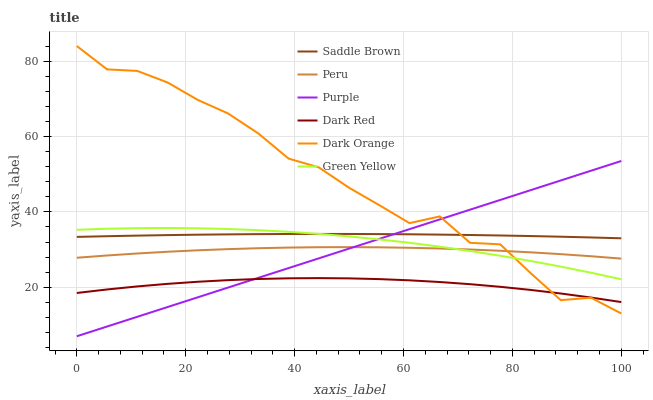Does Dark Red have the minimum area under the curve?
Answer yes or no. Yes. Does Dark Orange have the maximum area under the curve?
Answer yes or no. Yes. Does Purple have the minimum area under the curve?
Answer yes or no. No. Does Purple have the maximum area under the curve?
Answer yes or no. No. Is Purple the smoothest?
Answer yes or no. Yes. Is Dark Orange the roughest?
Answer yes or no. Yes. Is Dark Red the smoothest?
Answer yes or no. No. Is Dark Red the roughest?
Answer yes or no. No. Does Purple have the lowest value?
Answer yes or no. Yes. Does Dark Red have the lowest value?
Answer yes or no. No. Does Dark Orange have the highest value?
Answer yes or no. Yes. Does Purple have the highest value?
Answer yes or no. No. Is Dark Red less than Saddle Brown?
Answer yes or no. Yes. Is Peru greater than Dark Red?
Answer yes or no. Yes. Does Green Yellow intersect Dark Orange?
Answer yes or no. Yes. Is Green Yellow less than Dark Orange?
Answer yes or no. No. Is Green Yellow greater than Dark Orange?
Answer yes or no. No. Does Dark Red intersect Saddle Brown?
Answer yes or no. No. 